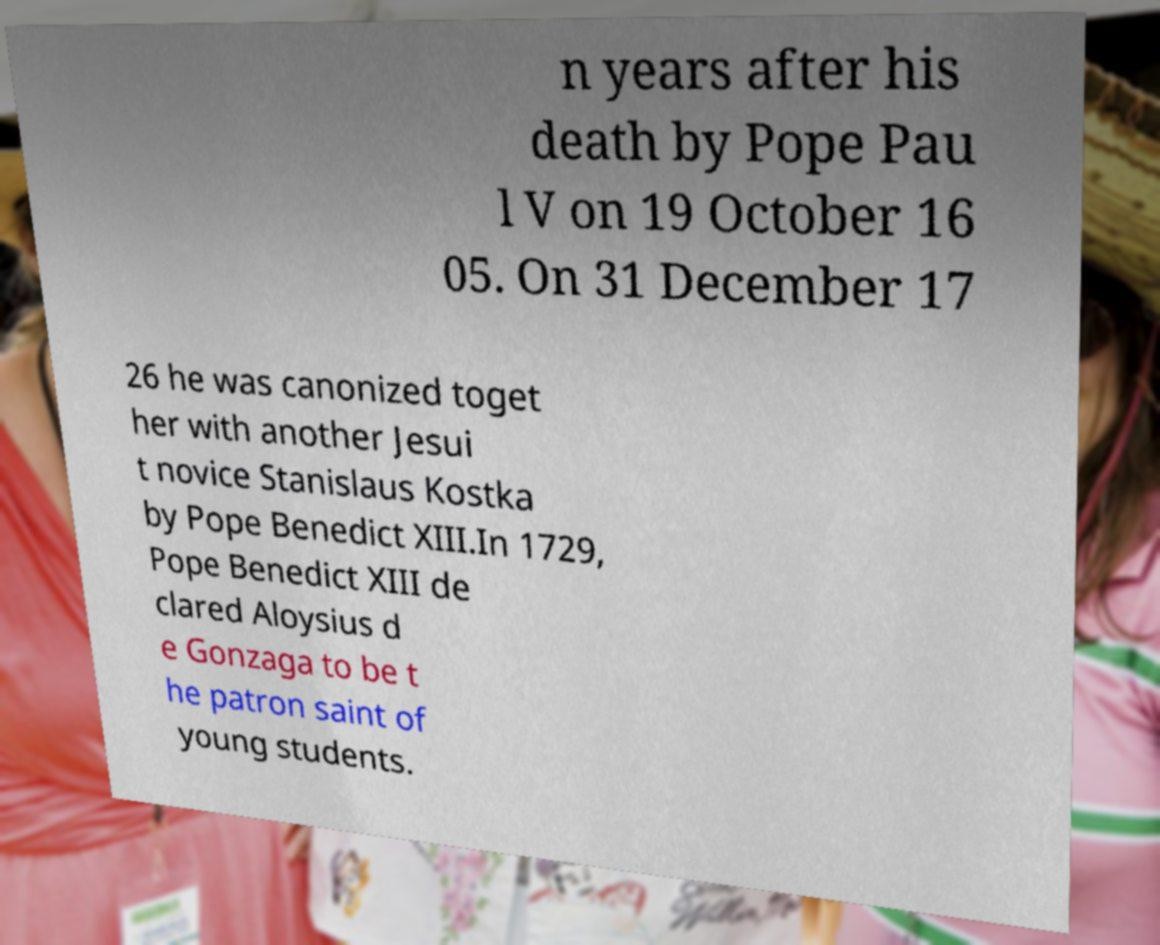What messages or text are displayed in this image? I need them in a readable, typed format. n years after his death by Pope Pau l V on 19 October 16 05. On 31 December 17 26 he was canonized toget her with another Jesui t novice Stanislaus Kostka by Pope Benedict XIII.In 1729, Pope Benedict XIII de clared Aloysius d e Gonzaga to be t he patron saint of young students. 